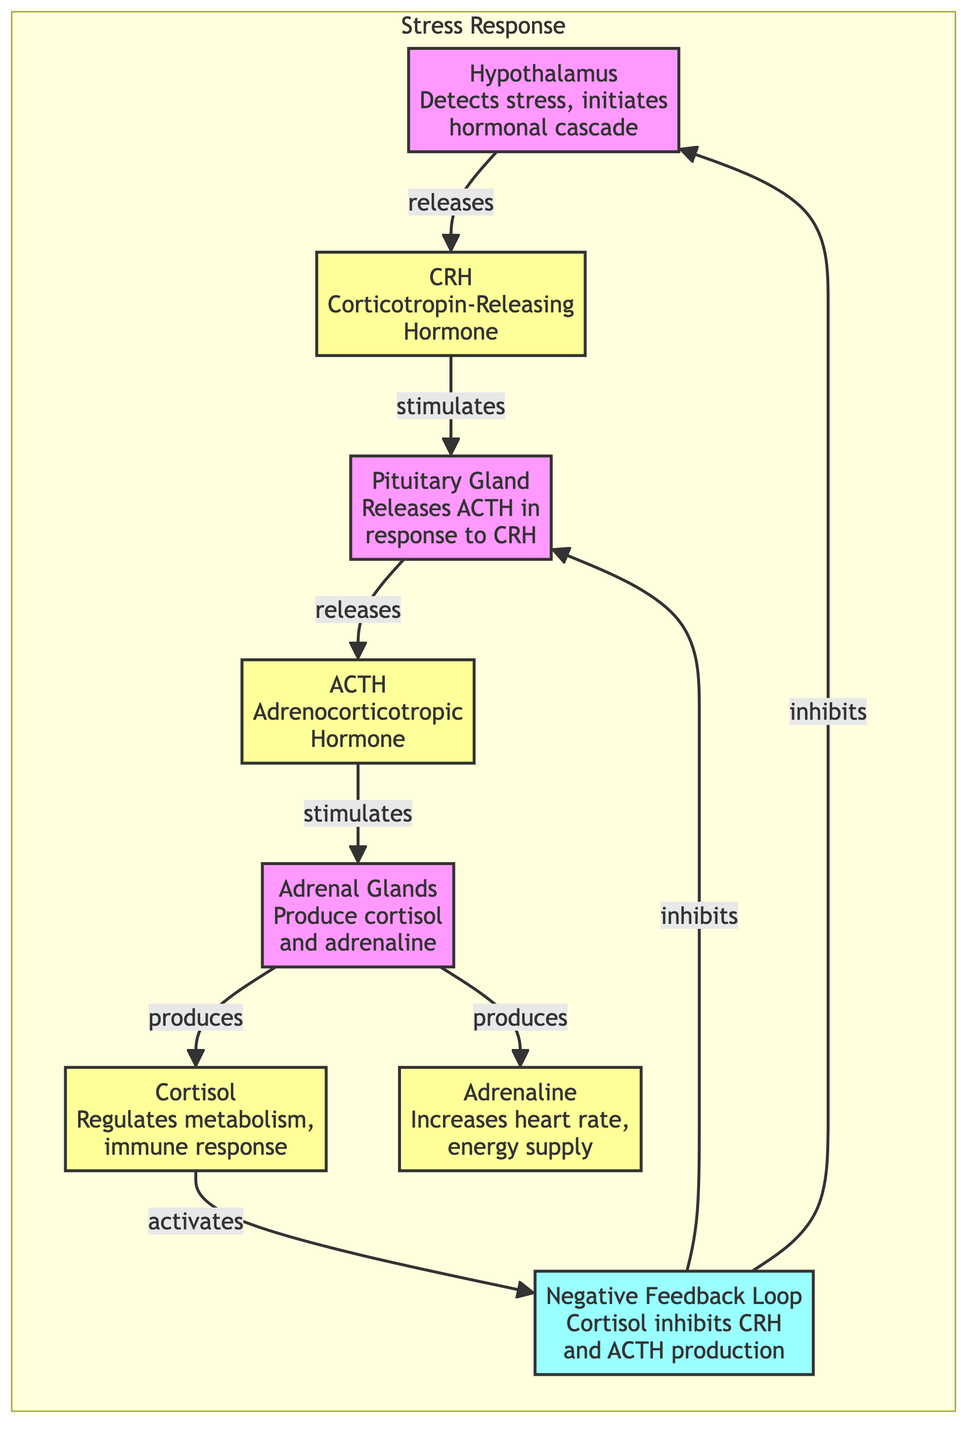What is the role of the hypothalamus in response to stress? The hypothalamus detects stress and initiates the hormonal cascade by releasing CRH. This is the initial step in the stress response pathway.
Answer: Detects stress, initiates hormonal cascade How many hormones are produced in the adrenal glands according to the diagram? The adrenal glands produce two hormones, cortisol and adrenaline, as indicated by their arrows stemming from the adrenal node.
Answer: Two Which hormone is released first in the cascade? The first hormone released in response to stress is CRH from the hypothalamus, which triggers the subsequent hormonal responses.
Answer: CRH What does cortisol do in the stress response? Cortisol regulates metabolism and the immune response, playing a significant role in how the body manages stress physiology.
Answer: Regulates metabolism, immune response How does the negative feedback loop affect hormone production? The negative feedback loop involves cortisol inhibiting the production of CRH and ACTH, which helps to regulate the stress response and prevent overactivation.
Answer: Inhibits CRH and ACTH production In the stress response pathway, what stimulates the adrenal glands? The adrenal glands are stimulated by ACTH released from the pituitary gland, which is part of the hormonal cascade in response to stress.
Answer: ACTH What is the final output of the adrenal glands? The final outputs of the adrenal glands are cortisol and adrenaline, which are crucial for the body's acute stress response.
Answer: Cortisol and adrenaline Which part of the diagram represents the feedback mechanism? The negative feedback loop is represented in the diagram, showing how cortisol inhibits signals from the hypothalamus and pituitary to control the stress response.
Answer: Negative Feedback Loop 